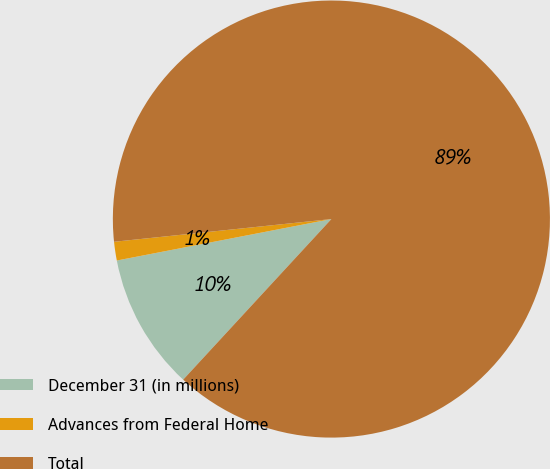Convert chart. <chart><loc_0><loc_0><loc_500><loc_500><pie_chart><fcel>December 31 (in millions)<fcel>Advances from Federal Home<fcel>Total<nl><fcel>10.1%<fcel>1.38%<fcel>88.52%<nl></chart> 